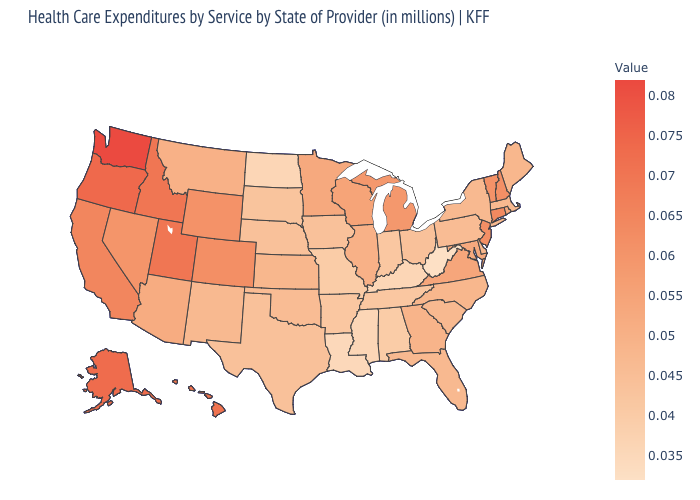Does West Virginia have the lowest value in the USA?
Answer briefly. Yes. Which states hav the highest value in the West?
Quick response, please. Washington. Does the map have missing data?
Concise answer only. No. Which states have the lowest value in the USA?
Answer briefly. West Virginia. Does Michigan have the highest value in the MidWest?
Concise answer only. Yes. Does South Carolina have the highest value in the USA?
Write a very short answer. No. Which states have the lowest value in the USA?
Concise answer only. West Virginia. 